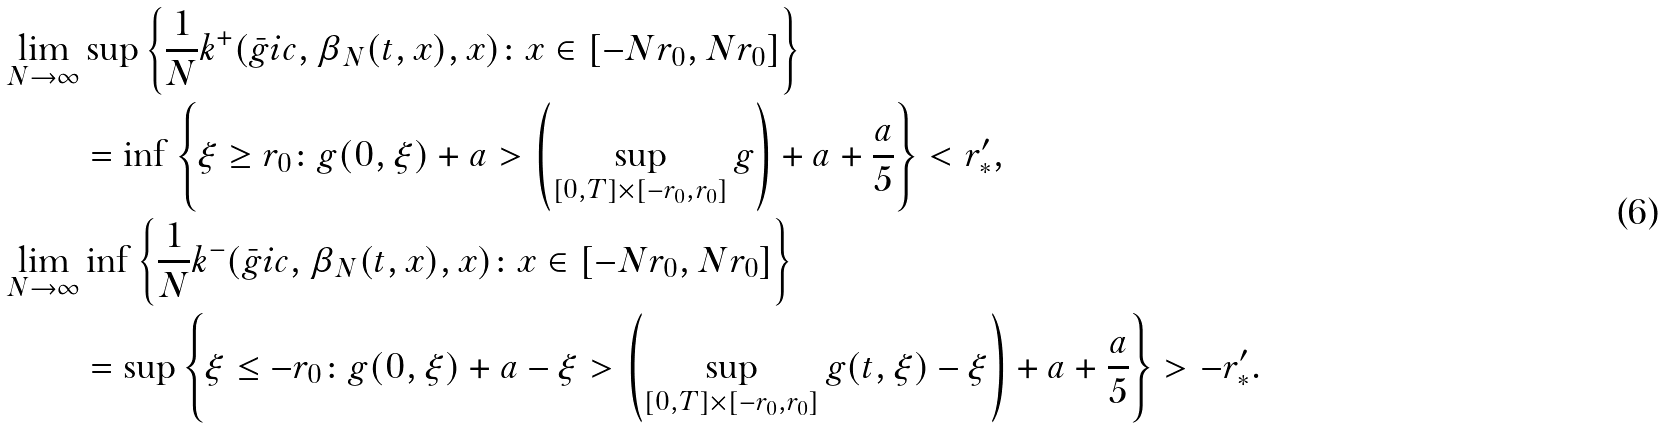Convert formula to latex. <formula><loc_0><loc_0><loc_500><loc_500>\lim _ { N \to \infty } & \sup \left \{ \frac { 1 } { N } k ^ { + } ( \bar { g } i c , \beta _ { N } ( t , x ) , x ) \colon x \in [ - N r _ { 0 } , N r _ { 0 } ] \right \} \\ & = \inf \left \{ \xi \geq r _ { 0 } \colon g ( 0 , \xi ) + a > \left ( \sup _ { [ 0 , T ] \times [ - r _ { 0 } , r _ { 0 } ] } g \right ) + a + \frac { a } { 5 } \right \} < r ^ { \prime } _ { * } , \\ \lim _ { N \to \infty } & \inf \left \{ \frac { 1 } { N } k ^ { - } ( \bar { g } i c , \beta _ { N } ( t , x ) , x ) \colon x \in [ - N r _ { 0 } , N r _ { 0 } ] \right \} \\ & = \sup \left \{ \xi \leq - r _ { 0 } \colon g ( 0 , \xi ) + a - \xi > \left ( \sup _ { [ 0 , T ] \times [ - r _ { 0 } , r _ { 0 } ] } g ( t , \xi ) - \xi \right ) + a + \frac { a } { 5 } \right \} > - r ^ { \prime } _ { * } .</formula> 